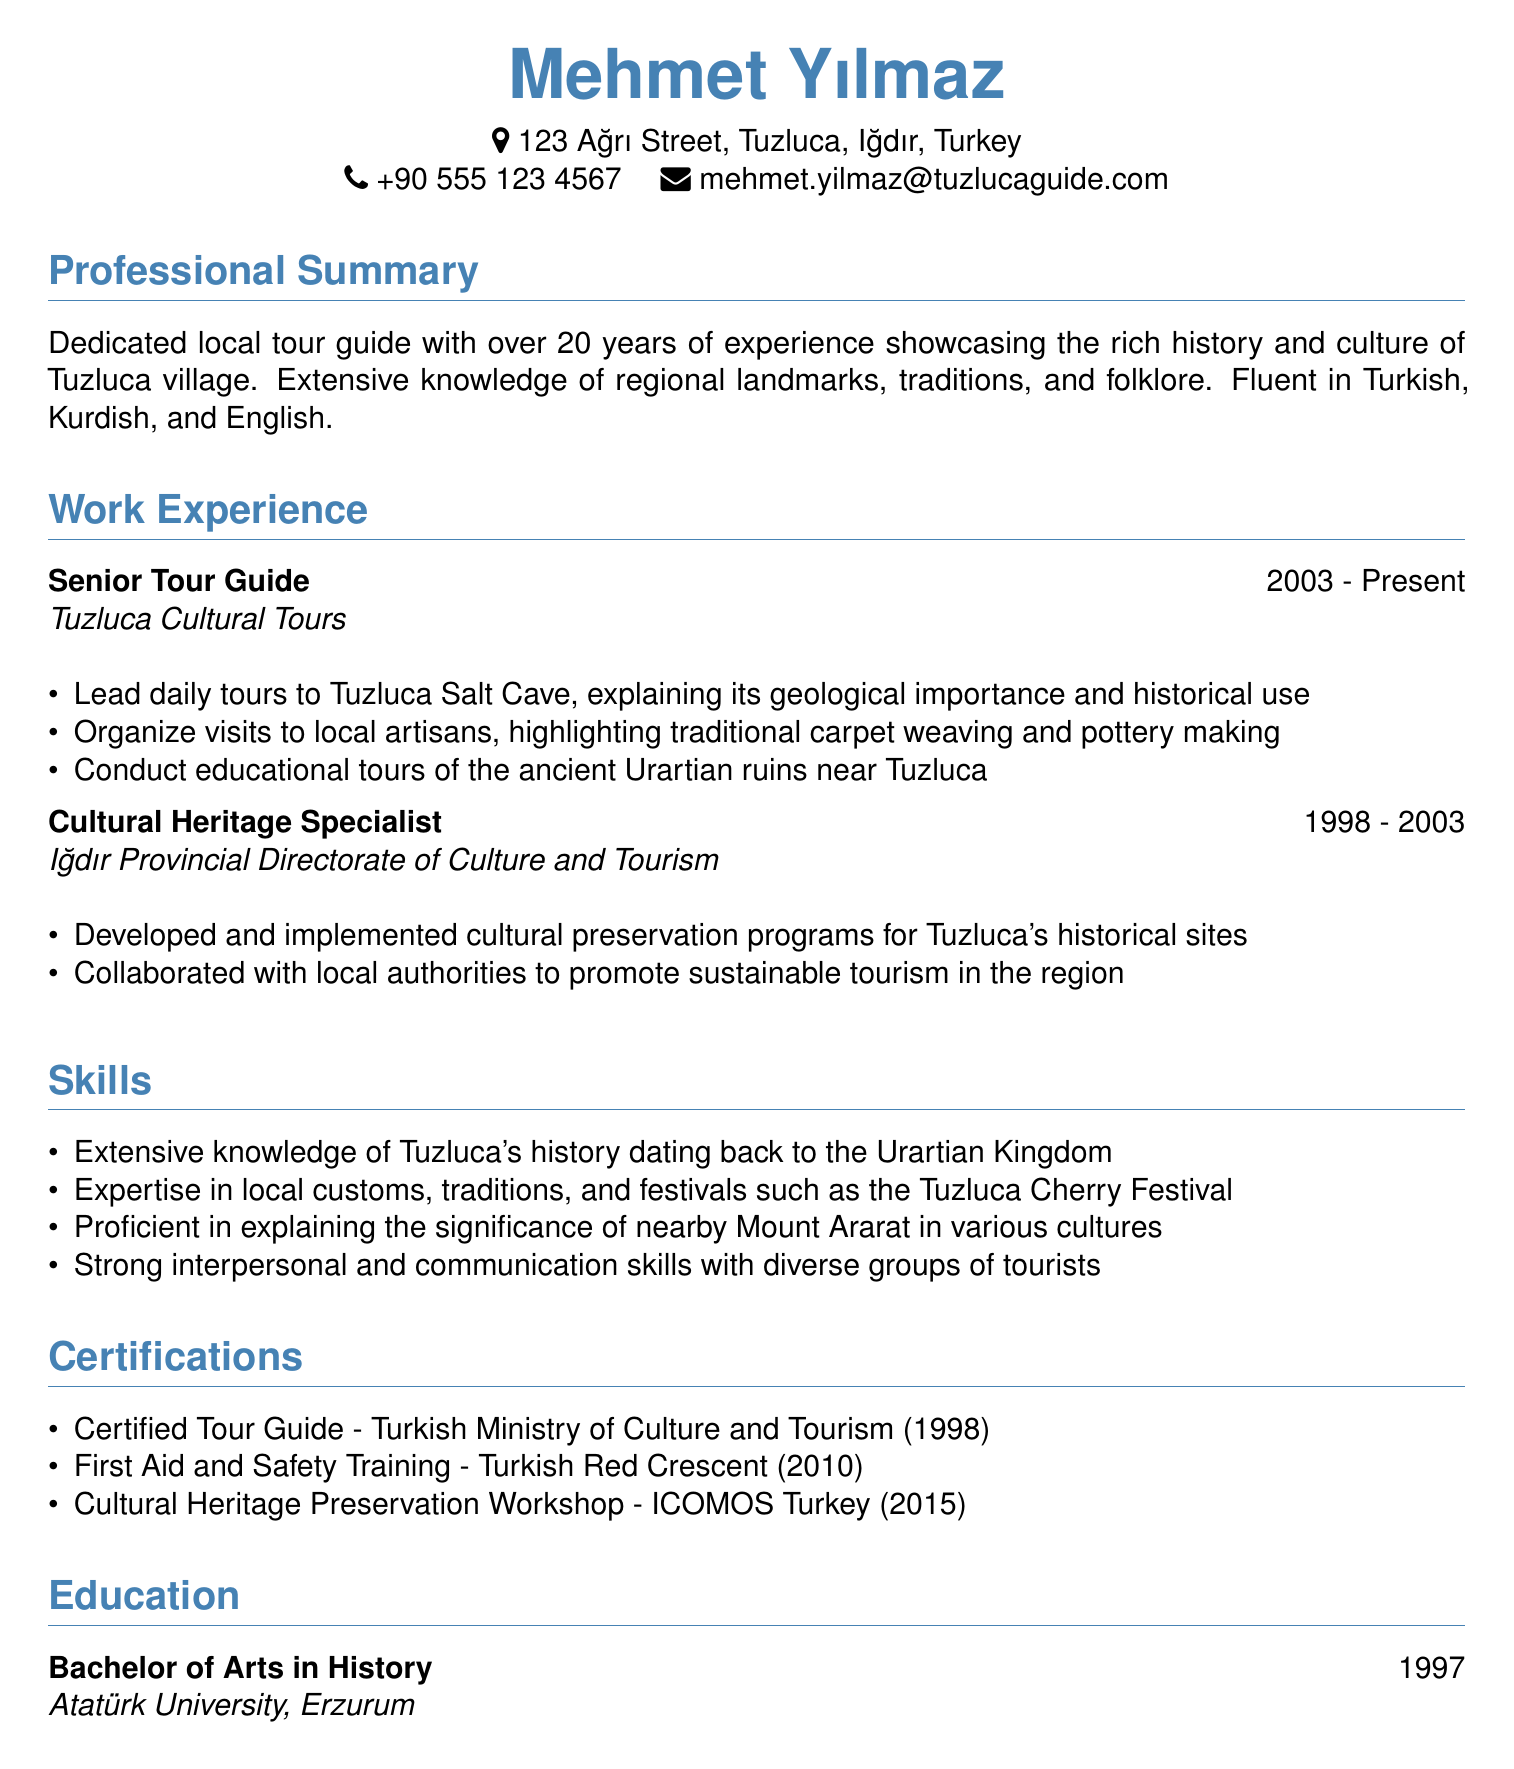what is the name of the tour guide? The name is listed as Mehmet Yılmaz in the document.
Answer: Mehmet Yılmaz how many years of experience does the tour guide have? The document states that the tour guide has over 20 years of experience.
Answer: over 20 years what is the position held at Tuzluca Cultural Tours? The document mentions the tour guide's position as Senior Tour Guide at Tuzluca Cultural Tours.
Answer: Senior Tour Guide what languages is the tour guide fluent in? The document lists Turkish, Kurdish, and English as the languages the tour guide is fluent in.
Answer: Turkish, Kurdish, and English which ancient ruins does the tour guide conduct educational tours of? The document specifies that the tour guide conducts educational tours of the ancient Urartian ruins near Tuzluca.
Answer: ancient Urartian ruins how many certifications does the tour guide have listed? The document lists three certifications that the tour guide has obtained.
Answer: three what type of degree does the tour guide hold? The document indicates that the tour guide holds a Bachelor of Arts in History.
Answer: Bachelor of Arts in History when did the tour guide begin working as a Cultural Heritage Specialist? The document states that the tour guide worked as a Cultural Heritage Specialist from 1998 to 2003.
Answer: 1998 what cultural festival is specifically mentioned in the skills section? The document refers to the Tuzluca Cherry Festival in the skills section.
Answer: Tuzluca Cherry Festival 